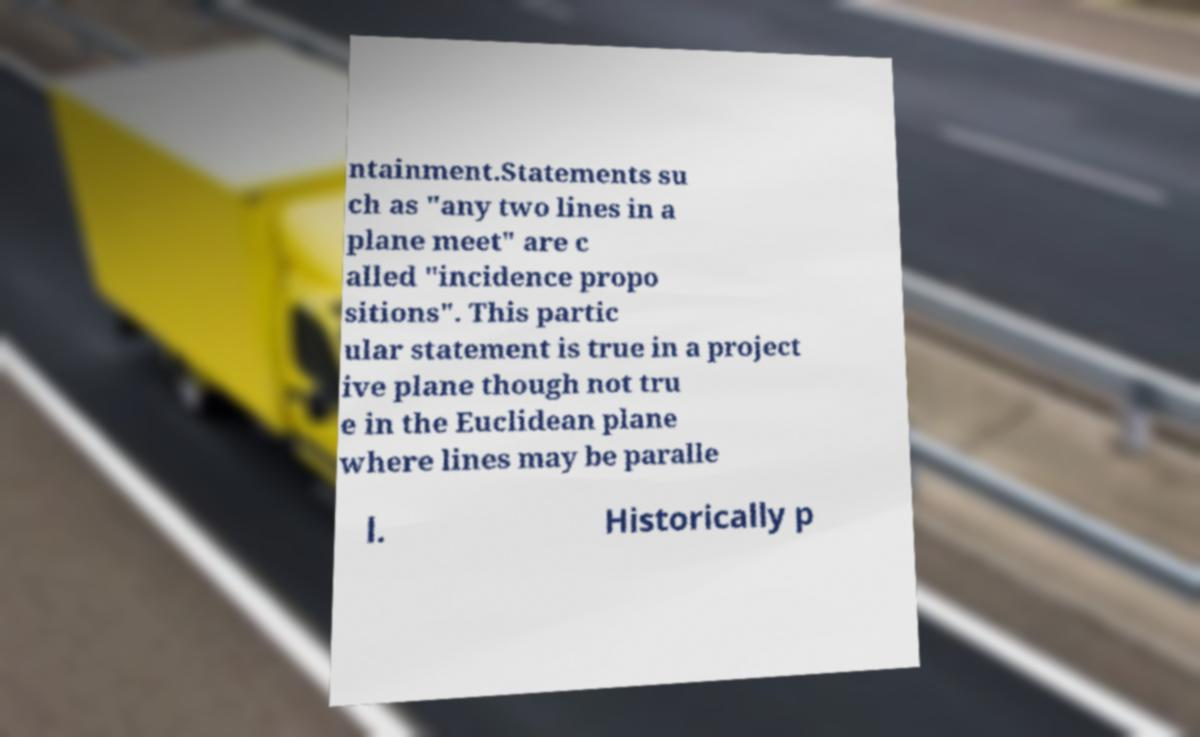Could you extract and type out the text from this image? ntainment.Statements su ch as "any two lines in a plane meet" are c alled "incidence propo sitions". This partic ular statement is true in a project ive plane though not tru e in the Euclidean plane where lines may be paralle l. Historically p 